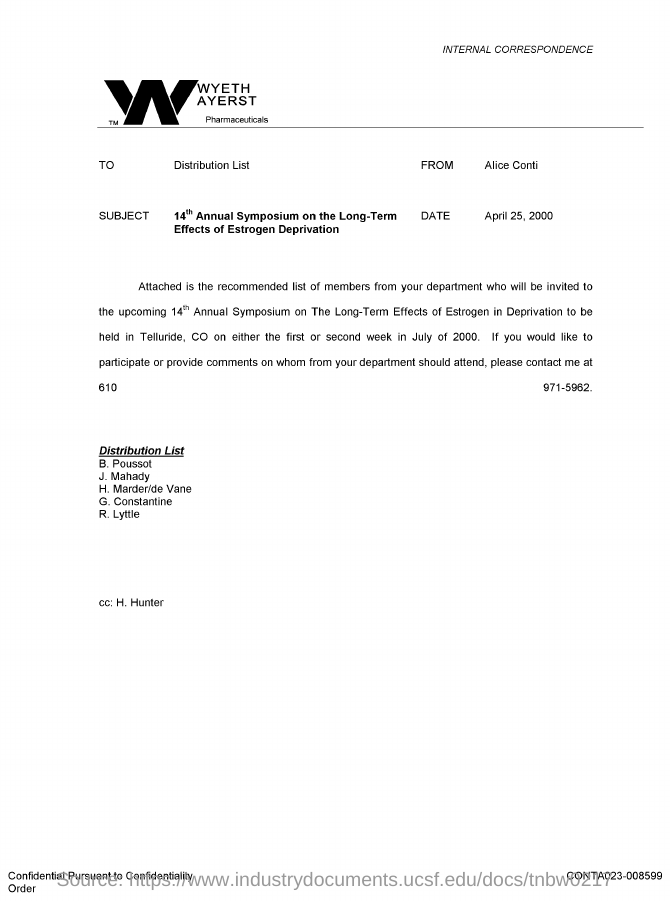Draw attention to some important aspects in this diagram. The issued date of this document is April 25, 2000. The recipient of the document is unknown, as it is addressed to a distribution list. The sender of this document is Alice Conti. 